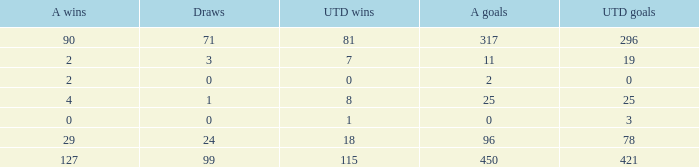I'm looking to parse the entire table for insights. Could you assist me with that? {'header': ['A wins', 'Draws', 'UTD wins', 'A goals', 'UTD goals'], 'rows': [['90', '71', '81', '317', '296'], ['2', '3', '7', '11', '19'], ['2', '0', '0', '2', '0'], ['4', '1', '8', '25', '25'], ['0', '0', '1', '0', '3'], ['29', '24', '18', '96', '78'], ['127', '99', '115', '450', '421']]} What is the lowest U Wins, when Alianza Wins is greater than 0, when Alianza Goals is greater than 25, and when Draws is "99"? 115.0. 